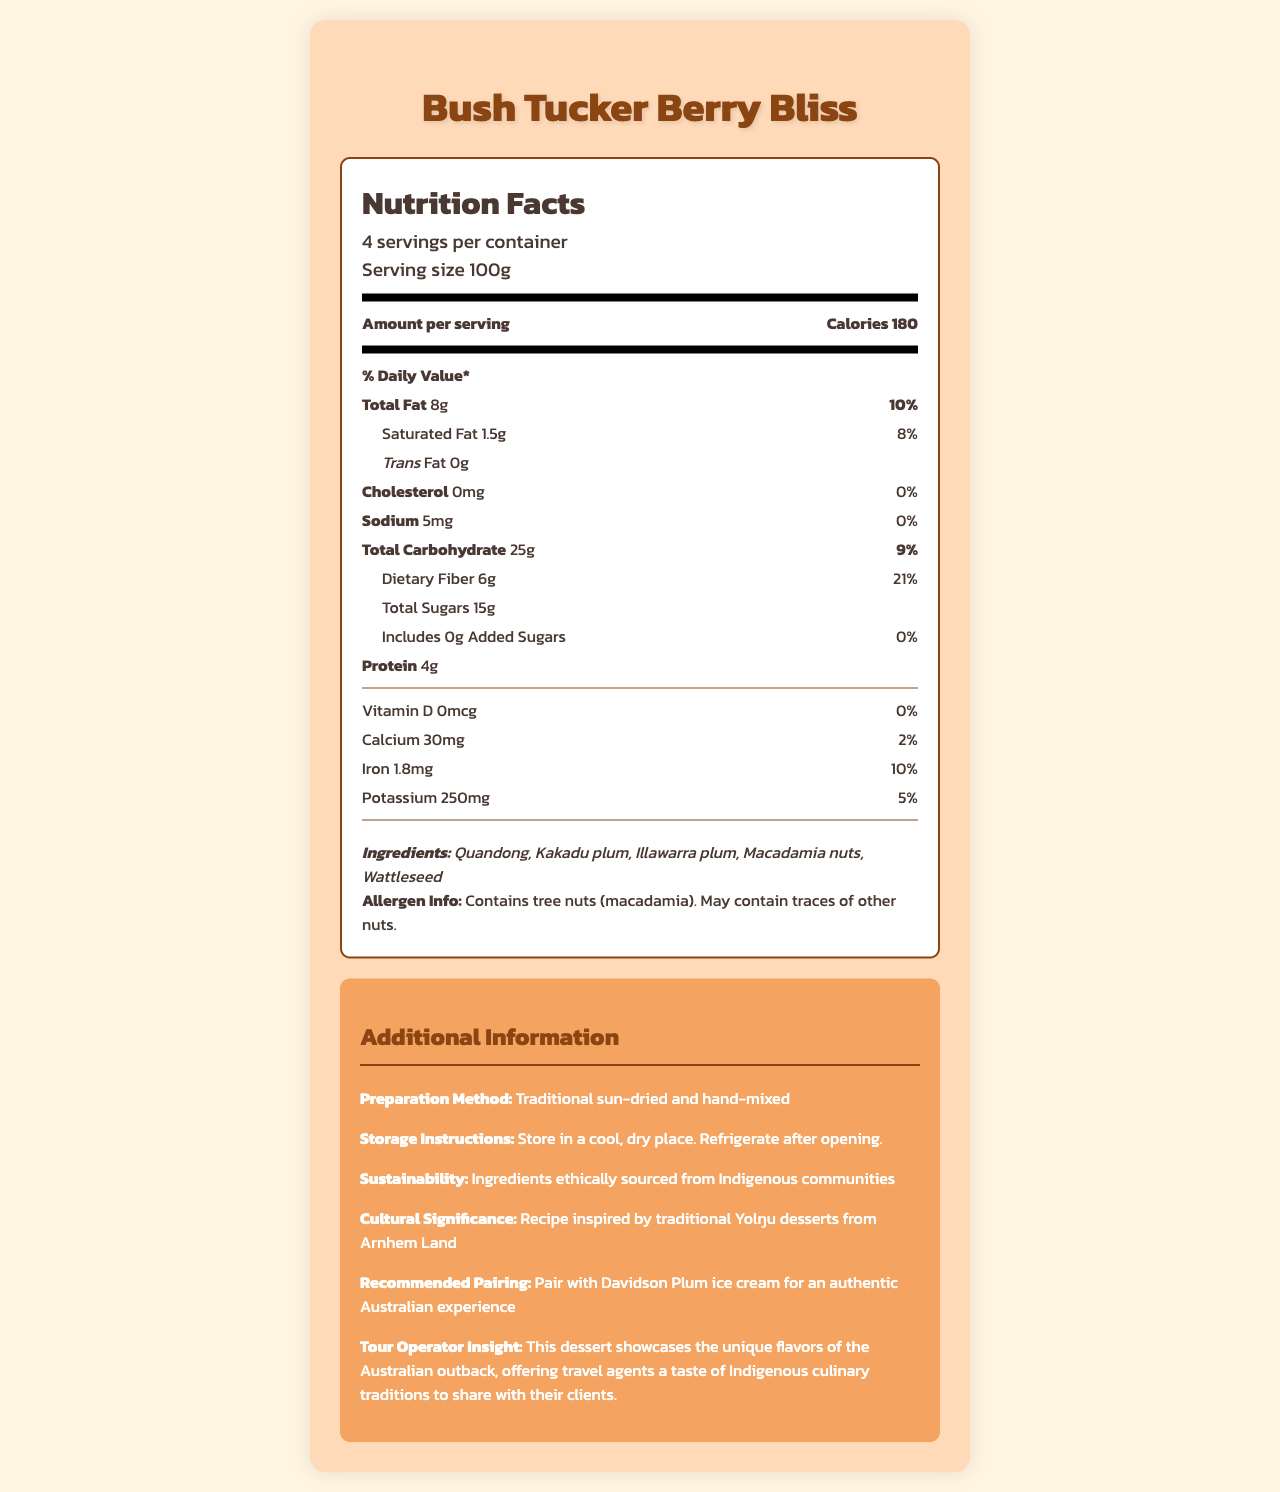what is the serving size? The document indicates that the serving size for Bush Tucker Berry Bliss is 100g.
Answer: 100g how many calories are there per serving? According to the document, there are 180 calories per serving.
Answer: 180 what is the total fat content per serving? The document states that the total fat content per serving is 8g.
Answer: 8g which indigenous fruits are included in the ingredients? The ingredients list in the document includes Quandong, Kakadu plum, and Illawarra plum.
Answer: Quandong, Kakadu plum, Illawarra plum what is the protein content per serving? The document provides the information that the protein content per serving is 4g.
Answer: 4g how much dietary fiber is in each serving? The nutrition label indicates that each serving contains 6g of dietary fiber.
Answer: 6g how is the dessert traditionally prepared? The document mentions that the dessert is traditionally sun-dried and hand-mixed.
Answer: Traditional sun-dried and hand-mixed what percentage of daily value of iron does each serving provide? The document specifies that each serving provides 10% of the daily value of iron.
Answer: 10% which nuts are included in the ingredients? The ingredients list in the document includes macadamia nuts.
Answer: Macadamia nuts where are the ingredients ethically sourced from? The sustainability section of the document states that the ingredients are ethically sourced from Indigenous communities.
Answer: Indigenous communities which vitamin is not present in the dessert? The nutrition label shows that the amount of Vitamin D is 0mcg, and thus not present.
Answer: Vitamin D what cultural significance does the dessert have? The document states the recipe is inspired by traditional Yolŋu desserts from Arnhem Land.
Answer: Recipe inspired by traditional Yolŋu desserts from Arnhem Land what does the allergen information indicate about tree nuts? The allergen information section indicates that it contains tree nuts (macadamia) and may contain traces of other nuts.
Answer: Contains tree nuts (macadamia). May contain traces of other nuts. Pairing the dessert with which ice cream enhances the authenticity? The document recommends pairing the dessert with Davidson Plum ice cream for an authentic Australian experience.
Answer: Davidson Plum ice cream what advice does the tour operator give regarding the dessert? The Tour Operator Insight section provides this advice.
Answer: This dessert showcases the unique flavors of the Australian outback, offering travel agents a taste of Indigenous culinary traditions to share with their clients. from which land is the recipe inspired? The document mentions that the recipe is inspired by traditional Yolŋu desserts from Arnhem Land.
Answer: Arnhem Land what is the storage instruction for the dessert? The storage instructions section states to store in a cool, dry place and refrigerate after opening.
Answer: Store in a cool, dry place. Refrigerate after opening. what is the calcium content per serving? The document specifies that each serving contains 30mg of calcium.
Answer: 30mg which components are included in the total carbohydrate content? A. Total Sugars, Dietary Fiber B. Total Fat, Protein C. Iron, Potassium The total carbohydrate content includes 25g of total carbohydrates, which consists of Total Sugars (15g) and Dietary Fiber (6g).
Answer: A how many servings are in each container? A. 2 B. 4 C. 6 The document indicates that there are 4 servings per container.
Answer: B does the dessert contain any added sugars? The document clearly states that there are 0g of added sugars per serving.
Answer: No is there any cholesterol in the dessert? The nutrition label shows there is 0mg of cholesterol per serving.
Answer: No what is the sodium intake per serving? According to the document, there is 5mg of sodium per serving.
Answer: 5mg is this dessert gluten-free? The document does not provide any information regarding whether the dessert is gluten-free.
Answer: Not enough information describe the document in a few sentences. The document is comprehensive, covering nutritional data, ingredients, allergen information, preparation details, storage recommendations, cultural significance, and pairing suggestions.
Answer: The document provides detailed nutrition information for a traditional Indigenous Australian dessert called Bush Tucker Berry Bliss. It includes data on serving size, calorie content, and various nutritional components such as fats, carbohydrates, sugars, fiber, and protein. Additionally, it lists ingredients, allergen information, preparation methods, and cultural significance, along with recommendations for pairing and storage instructions. 